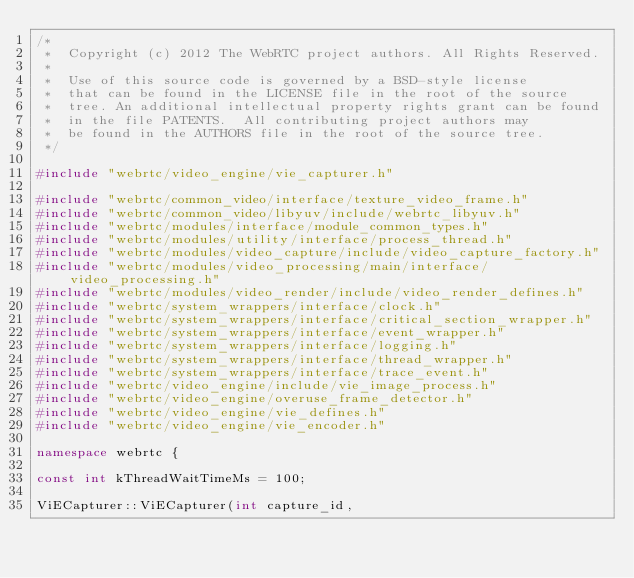<code> <loc_0><loc_0><loc_500><loc_500><_C++_>/*
 *  Copyright (c) 2012 The WebRTC project authors. All Rights Reserved.
 *
 *  Use of this source code is governed by a BSD-style license
 *  that can be found in the LICENSE file in the root of the source
 *  tree. An additional intellectual property rights grant can be found
 *  in the file PATENTS.  All contributing project authors may
 *  be found in the AUTHORS file in the root of the source tree.
 */

#include "webrtc/video_engine/vie_capturer.h"

#include "webrtc/common_video/interface/texture_video_frame.h"
#include "webrtc/common_video/libyuv/include/webrtc_libyuv.h"
#include "webrtc/modules/interface/module_common_types.h"
#include "webrtc/modules/utility/interface/process_thread.h"
#include "webrtc/modules/video_capture/include/video_capture_factory.h"
#include "webrtc/modules/video_processing/main/interface/video_processing.h"
#include "webrtc/modules/video_render/include/video_render_defines.h"
#include "webrtc/system_wrappers/interface/clock.h"
#include "webrtc/system_wrappers/interface/critical_section_wrapper.h"
#include "webrtc/system_wrappers/interface/event_wrapper.h"
#include "webrtc/system_wrappers/interface/logging.h"
#include "webrtc/system_wrappers/interface/thread_wrapper.h"
#include "webrtc/system_wrappers/interface/trace_event.h"
#include "webrtc/video_engine/include/vie_image_process.h"
#include "webrtc/video_engine/overuse_frame_detector.h"
#include "webrtc/video_engine/vie_defines.h"
#include "webrtc/video_engine/vie_encoder.h"

namespace webrtc {

const int kThreadWaitTimeMs = 100;

ViECapturer::ViECapturer(int capture_id,</code> 